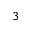Convert formula to latex. <formula><loc_0><loc_0><loc_500><loc_500>^ { 3 }</formula> 